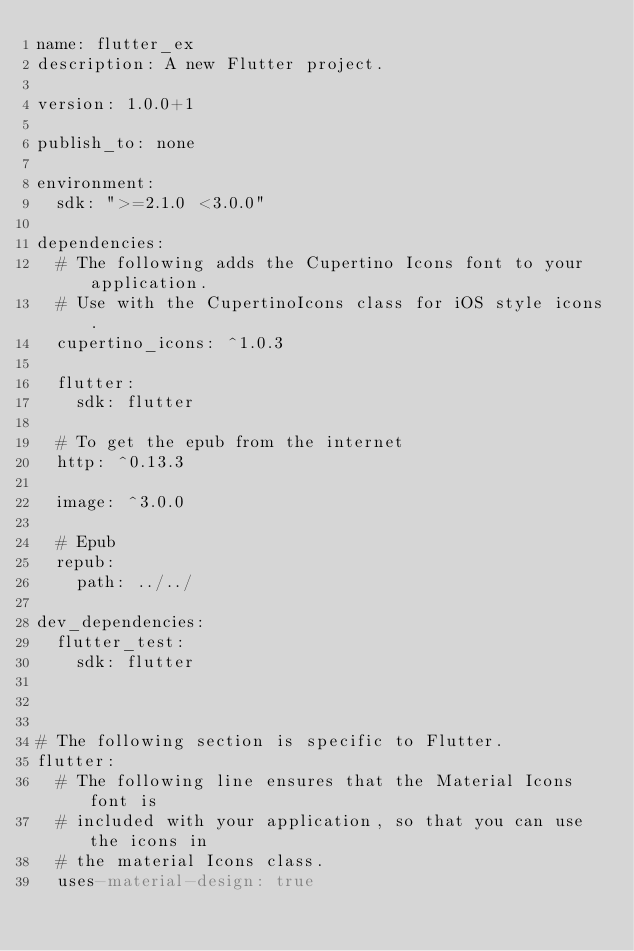Convert code to text. <code><loc_0><loc_0><loc_500><loc_500><_YAML_>name: flutter_ex
description: A new Flutter project.

version: 1.0.0+1

publish_to: none

environment:
  sdk: ">=2.1.0 <3.0.0"

dependencies:
  # The following adds the Cupertino Icons font to your application.
  # Use with the CupertinoIcons class for iOS style icons.
  cupertino_icons: ^1.0.3

  flutter:
    sdk: flutter

  # To get the epub from the internet
  http: ^0.13.3

  image: ^3.0.0

  # Epub
  repub:
    path: ../../

dev_dependencies:
  flutter_test:
    sdk: flutter



# The following section is specific to Flutter.
flutter:
  # The following line ensures that the Material Icons font is
  # included with your application, so that you can use the icons in
  # the material Icons class.
  uses-material-design: true
</code> 